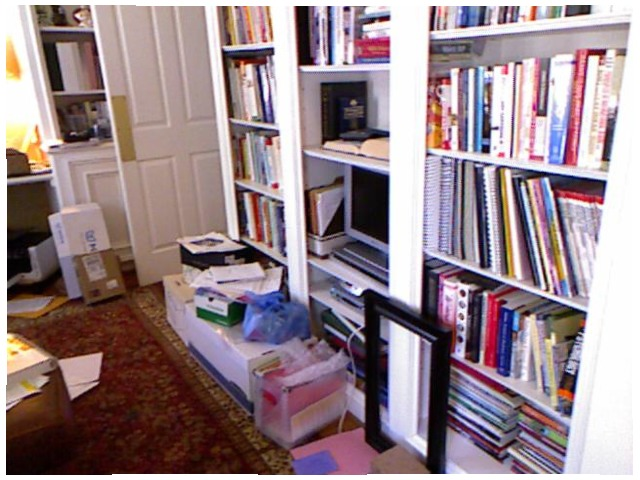<image>
Is there a paper on the carpet? Yes. Looking at the image, I can see the paper is positioned on top of the carpet, with the carpet providing support. Is the books on the cupboard? Yes. Looking at the image, I can see the books is positioned on top of the cupboard, with the cupboard providing support. Is there a computer on the book? No. The computer is not positioned on the book. They may be near each other, but the computer is not supported by or resting on top of the book. Where is the picture frame in relation to the rug? Is it on the rug? No. The picture frame is not positioned on the rug. They may be near each other, but the picture frame is not supported by or resting on top of the rug. Where is the computer in relation to the books? Is it to the right of the books? Yes. From this viewpoint, the computer is positioned to the right side relative to the books. 